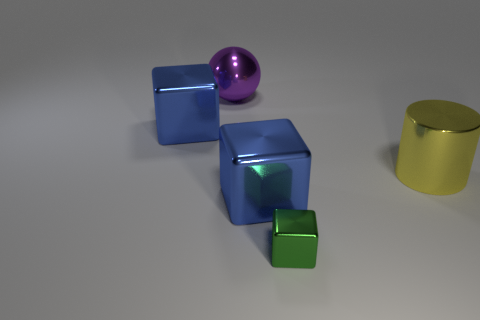What number of large things are right of the small green shiny thing and left of the large yellow thing?
Offer a terse response. 0. Do the blue cube that is on the right side of the purple thing and the purple object that is left of the big yellow thing have the same size?
Provide a short and direct response. Yes. How big is the green metal block that is in front of the big purple shiny thing?
Ensure brevity in your answer.  Small. How many things are big cubes in front of the large yellow cylinder or large things that are to the left of the big yellow metal cylinder?
Your response must be concise. 3. Is there anything else of the same color as the big sphere?
Provide a short and direct response. No. Are there an equal number of green cubes that are to the right of the yellow cylinder and tiny shiny things that are in front of the green object?
Make the answer very short. Yes. Are there more large metal spheres that are on the right side of the small cube than big blue metallic blocks?
Your answer should be very brief. No. How many objects are either big blue metal cubes that are in front of the yellow metallic cylinder or green metal things?
Offer a terse response. 2. How many blue cubes have the same material as the big sphere?
Provide a short and direct response. 2. Is there another small metal object of the same shape as the tiny thing?
Give a very brief answer. No. 